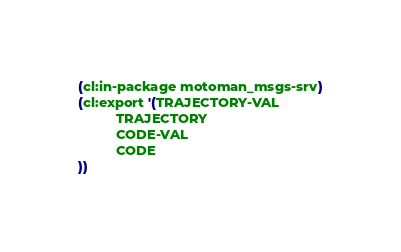<code> <loc_0><loc_0><loc_500><loc_500><_Lisp_>(cl:in-package motoman_msgs-srv)
(cl:export '(TRAJECTORY-VAL
          TRAJECTORY
          CODE-VAL
          CODE
))</code> 